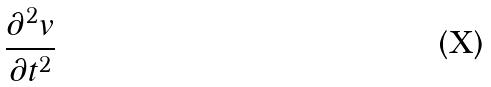<formula> <loc_0><loc_0><loc_500><loc_500>\frac { \partial ^ { 2 } v } { \partial t ^ { 2 } }</formula> 